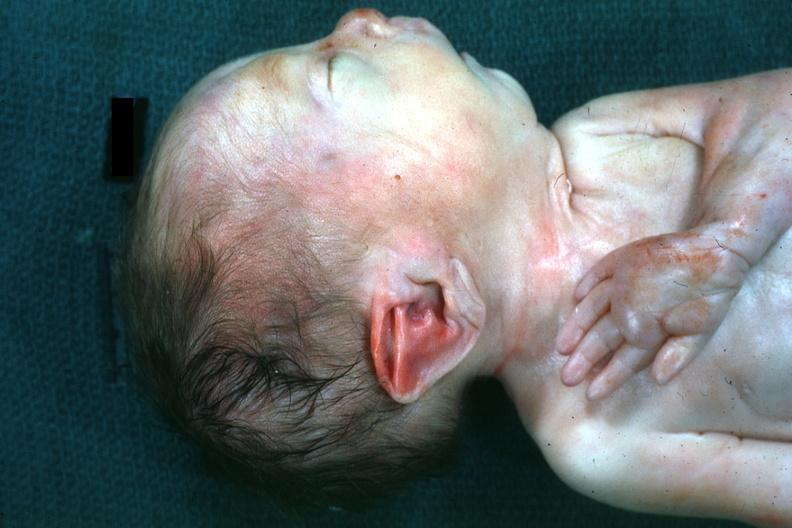s face present?
Answer the question using a single word or phrase. Yes 